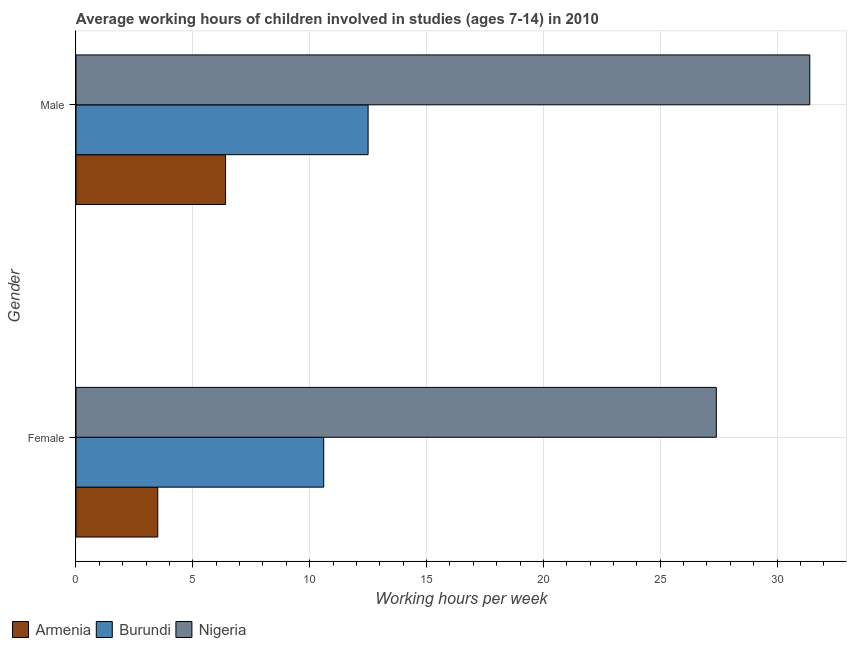How many different coloured bars are there?
Ensure brevity in your answer.  3. How many groups of bars are there?
Your answer should be compact. 2. Are the number of bars on each tick of the Y-axis equal?
Your response must be concise. Yes. How many bars are there on the 2nd tick from the bottom?
Your answer should be very brief. 3. What is the label of the 2nd group of bars from the top?
Offer a very short reply. Female. Across all countries, what is the maximum average working hour of female children?
Provide a short and direct response. 27.4. In which country was the average working hour of female children maximum?
Give a very brief answer. Nigeria. In which country was the average working hour of female children minimum?
Offer a very short reply. Armenia. What is the total average working hour of female children in the graph?
Provide a succinct answer. 41.5. What is the difference between the average working hour of female children in Nigeria and the average working hour of male children in Armenia?
Provide a succinct answer. 21. What is the average average working hour of female children per country?
Make the answer very short. 13.83. What is the difference between the average working hour of male children and average working hour of female children in Burundi?
Provide a short and direct response. 1.9. In how many countries, is the average working hour of female children greater than 20 hours?
Your answer should be compact. 1. What is the ratio of the average working hour of female children in Nigeria to that in Armenia?
Offer a very short reply. 7.83. In how many countries, is the average working hour of female children greater than the average average working hour of female children taken over all countries?
Keep it short and to the point. 1. What does the 2nd bar from the top in Male represents?
Provide a succinct answer. Burundi. What does the 3rd bar from the bottom in Male represents?
Your answer should be compact. Nigeria. How many bars are there?
Your answer should be very brief. 6. Are all the bars in the graph horizontal?
Your answer should be very brief. Yes. How many countries are there in the graph?
Give a very brief answer. 3. Does the graph contain any zero values?
Provide a succinct answer. No. Does the graph contain grids?
Ensure brevity in your answer.  Yes. How many legend labels are there?
Provide a succinct answer. 3. How are the legend labels stacked?
Offer a terse response. Horizontal. What is the title of the graph?
Give a very brief answer. Average working hours of children involved in studies (ages 7-14) in 2010. What is the label or title of the X-axis?
Make the answer very short. Working hours per week. What is the label or title of the Y-axis?
Your answer should be compact. Gender. What is the Working hours per week in Armenia in Female?
Provide a short and direct response. 3.5. What is the Working hours per week in Nigeria in Female?
Your answer should be compact. 27.4. What is the Working hours per week in Nigeria in Male?
Your answer should be compact. 31.4. Across all Gender, what is the maximum Working hours per week of Armenia?
Provide a short and direct response. 6.4. Across all Gender, what is the maximum Working hours per week in Burundi?
Ensure brevity in your answer.  12.5. Across all Gender, what is the maximum Working hours per week in Nigeria?
Ensure brevity in your answer.  31.4. Across all Gender, what is the minimum Working hours per week in Nigeria?
Keep it short and to the point. 27.4. What is the total Working hours per week of Armenia in the graph?
Provide a short and direct response. 9.9. What is the total Working hours per week of Burundi in the graph?
Offer a very short reply. 23.1. What is the total Working hours per week in Nigeria in the graph?
Make the answer very short. 58.8. What is the difference between the Working hours per week in Armenia in Female and that in Male?
Provide a short and direct response. -2.9. What is the difference between the Working hours per week in Burundi in Female and that in Male?
Give a very brief answer. -1.9. What is the difference between the Working hours per week of Armenia in Female and the Working hours per week of Burundi in Male?
Offer a terse response. -9. What is the difference between the Working hours per week in Armenia in Female and the Working hours per week in Nigeria in Male?
Provide a short and direct response. -27.9. What is the difference between the Working hours per week of Burundi in Female and the Working hours per week of Nigeria in Male?
Keep it short and to the point. -20.8. What is the average Working hours per week of Armenia per Gender?
Keep it short and to the point. 4.95. What is the average Working hours per week in Burundi per Gender?
Your response must be concise. 11.55. What is the average Working hours per week of Nigeria per Gender?
Your answer should be compact. 29.4. What is the difference between the Working hours per week of Armenia and Working hours per week of Burundi in Female?
Offer a terse response. -7.1. What is the difference between the Working hours per week of Armenia and Working hours per week of Nigeria in Female?
Give a very brief answer. -23.9. What is the difference between the Working hours per week of Burundi and Working hours per week of Nigeria in Female?
Make the answer very short. -16.8. What is the difference between the Working hours per week in Burundi and Working hours per week in Nigeria in Male?
Ensure brevity in your answer.  -18.9. What is the ratio of the Working hours per week of Armenia in Female to that in Male?
Keep it short and to the point. 0.55. What is the ratio of the Working hours per week in Burundi in Female to that in Male?
Provide a short and direct response. 0.85. What is the ratio of the Working hours per week in Nigeria in Female to that in Male?
Your answer should be compact. 0.87. What is the difference between the highest and the second highest Working hours per week in Armenia?
Your response must be concise. 2.9. What is the difference between the highest and the second highest Working hours per week in Burundi?
Your response must be concise. 1.9. What is the difference between the highest and the lowest Working hours per week in Armenia?
Ensure brevity in your answer.  2.9. 